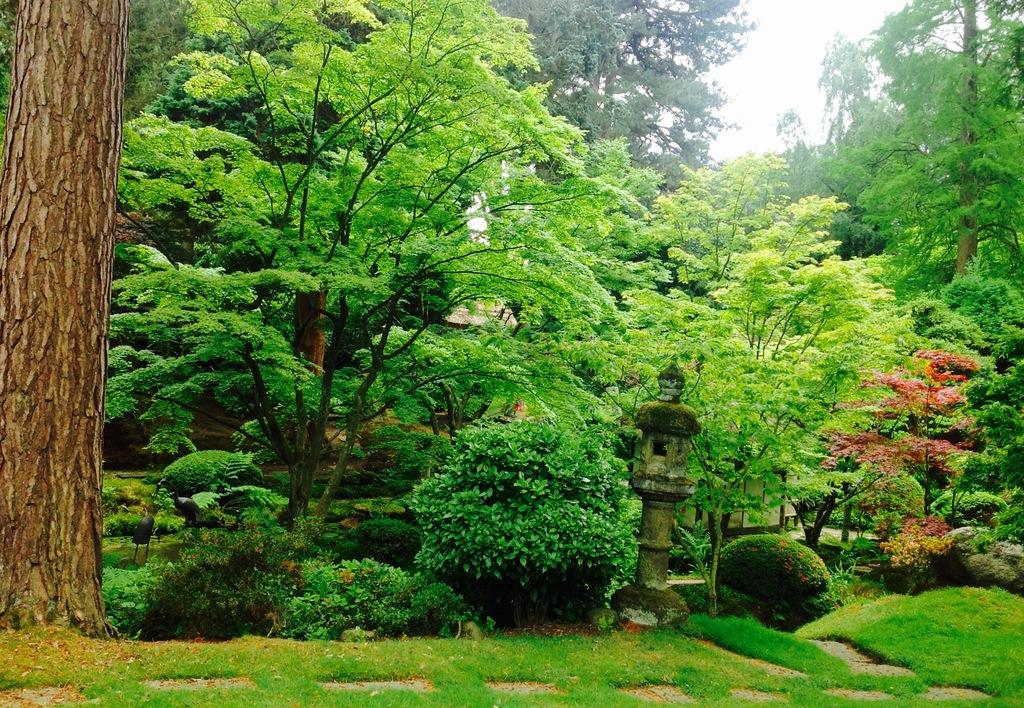What is the primary feature of the image? The primary feature of the image is the many trees. Is there any other object or structure visible in the image? Yes, there is a pole on the ground in front of the trees. What can be seen in the background of the image? The sky is visible in the background of the image, and it appears to be white. Can you tell me how many maids are working in the image? There are no maids present in the image; it features trees and a pole. What type of attraction is depicted in the image? There is no specific attraction depicted in the image; it simply shows trees, a pole, and a white sky. 